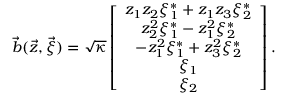Convert formula to latex. <formula><loc_0><loc_0><loc_500><loc_500>\vec { b } ( \vec { z } , \vec { \xi } ) = \sqrt { \kappa } \left [ \begin{array} { c } { z _ { 1 } z _ { 2 } \xi _ { 1 } ^ { * } + z _ { 1 } z _ { 3 } \xi _ { 2 } ^ { * } } \\ { z _ { 2 } ^ { 2 } \xi _ { 1 } ^ { * } - z _ { 1 } ^ { 2 } \xi _ { 2 } ^ { * } } \\ { - z _ { 1 } ^ { 2 } \xi _ { 1 } ^ { * } + z _ { 3 } ^ { 2 } \xi _ { 2 } ^ { * } } \\ { \xi _ { 1 } } \\ { \xi _ { 2 } } \end{array} \right ] .</formula> 